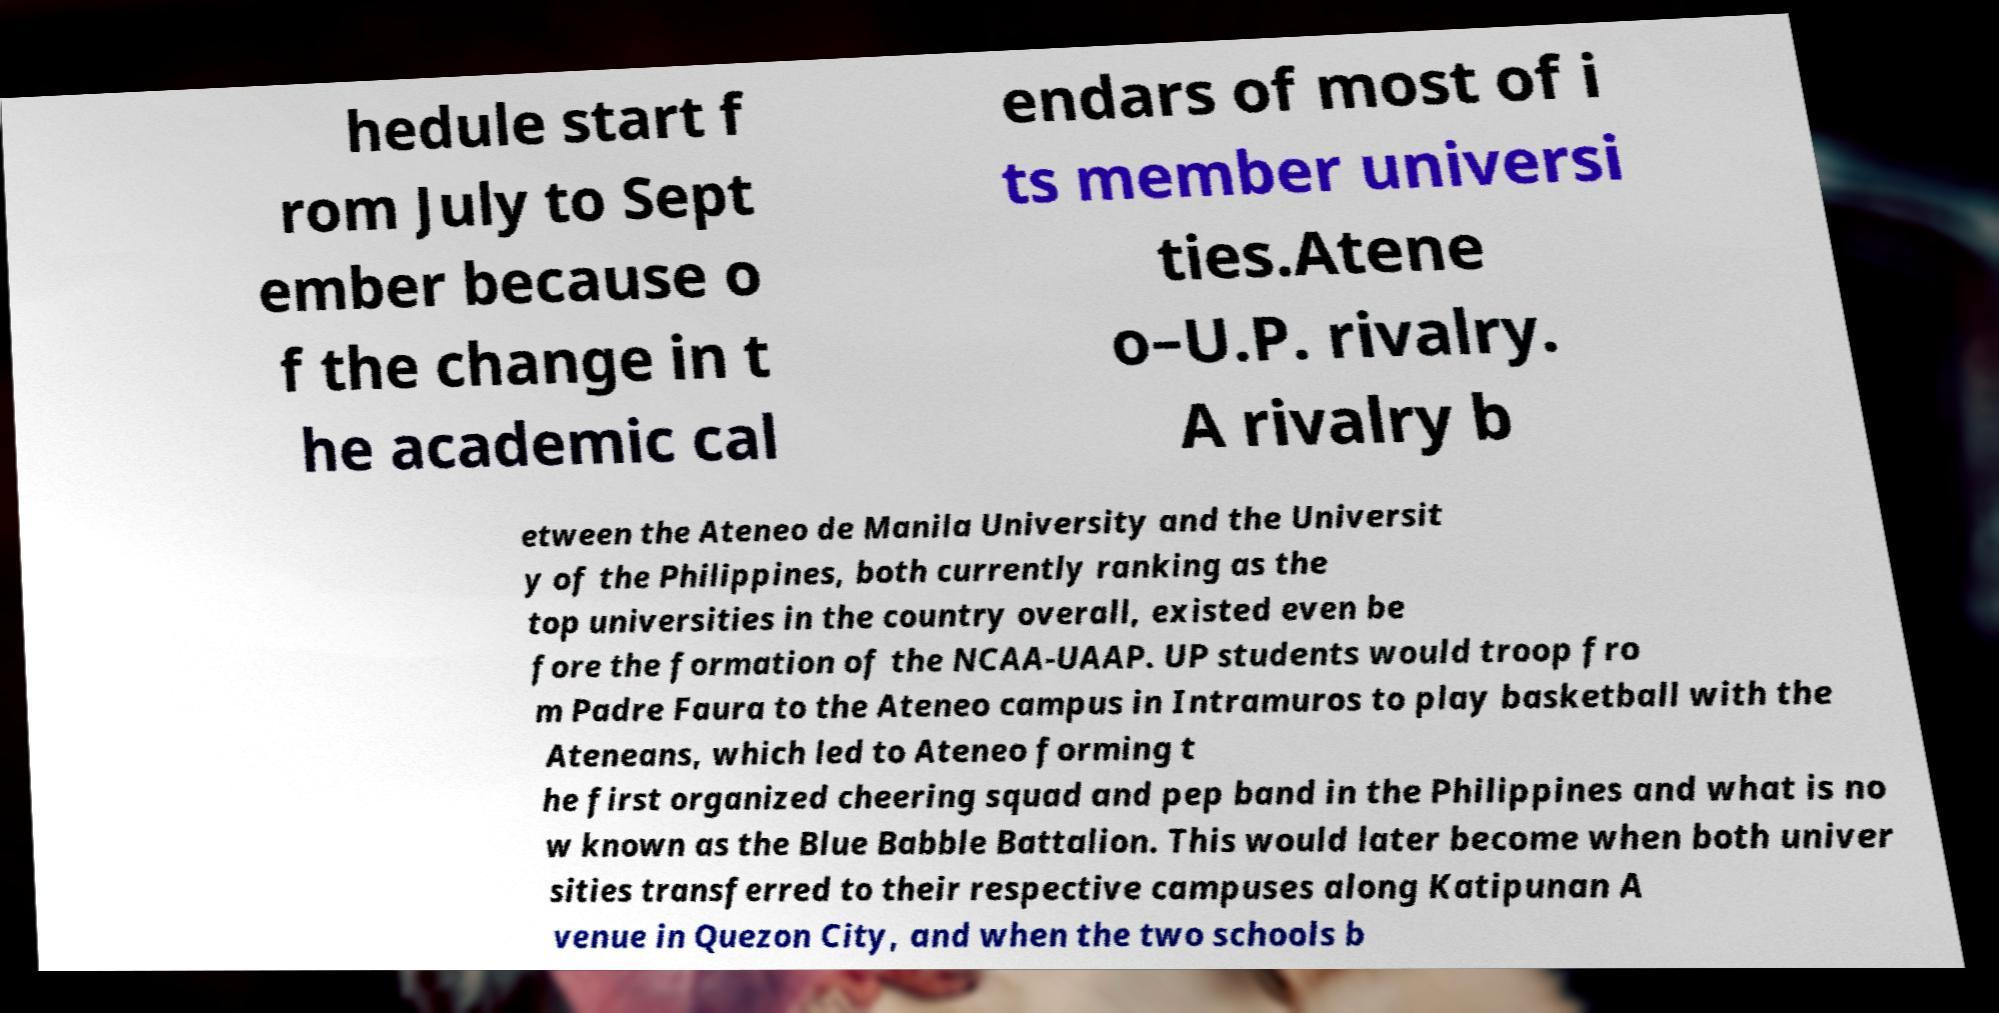For documentation purposes, I need the text within this image transcribed. Could you provide that? hedule start f rom July to Sept ember because o f the change in t he academic cal endars of most of i ts member universi ties.Atene o–U.P. rivalry. A rivalry b etween the Ateneo de Manila University and the Universit y of the Philippines, both currently ranking as the top universities in the country overall, existed even be fore the formation of the NCAA-UAAP. UP students would troop fro m Padre Faura to the Ateneo campus in Intramuros to play basketball with the Ateneans, which led to Ateneo forming t he first organized cheering squad and pep band in the Philippines and what is no w known as the Blue Babble Battalion. This would later become when both univer sities transferred to their respective campuses along Katipunan A venue in Quezon City, and when the two schools b 